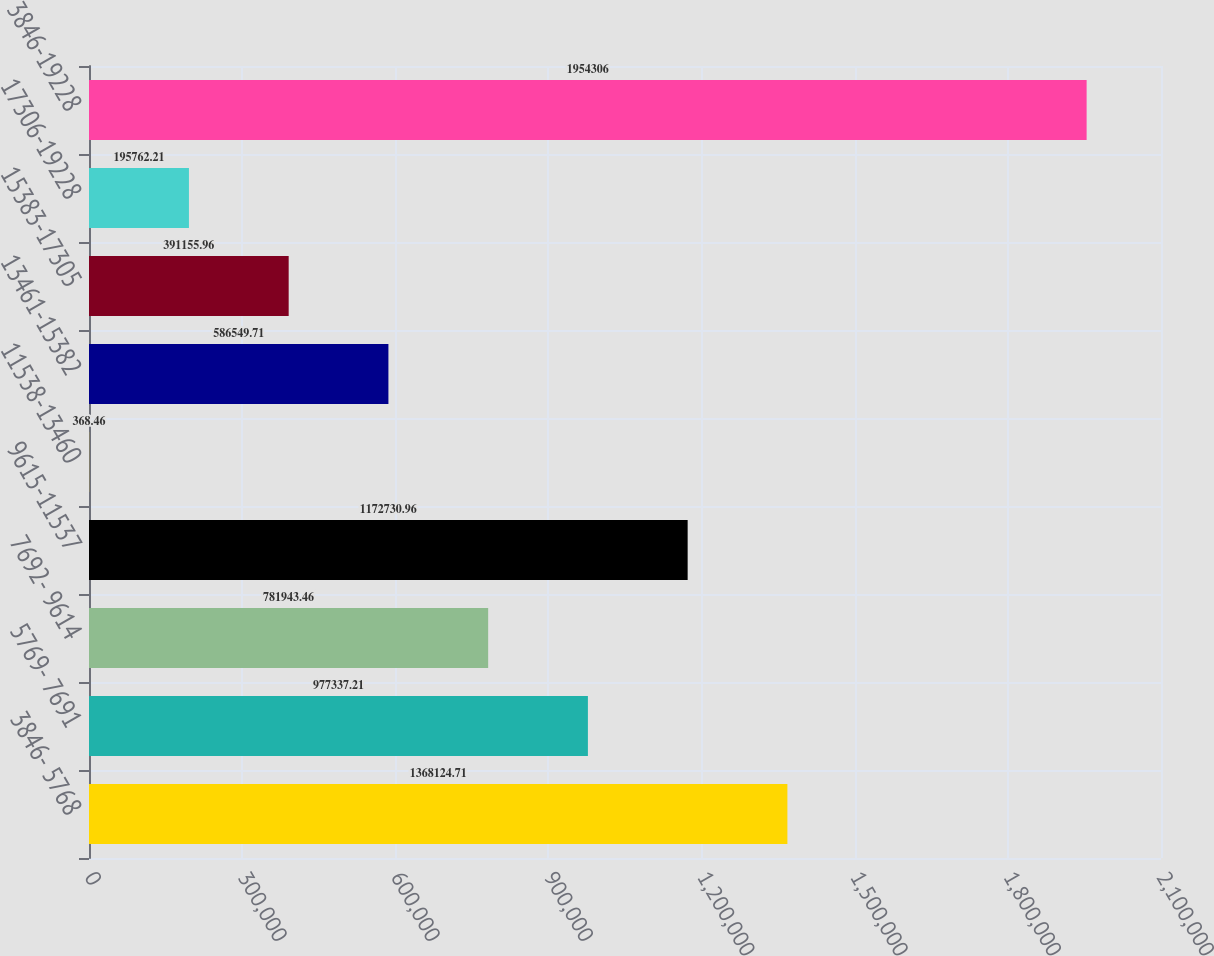<chart> <loc_0><loc_0><loc_500><loc_500><bar_chart><fcel>3846- 5768<fcel>5769- 7691<fcel>7692- 9614<fcel>9615-11537<fcel>11538-13460<fcel>13461-15382<fcel>15383-17305<fcel>17306-19228<fcel>3846-19228<nl><fcel>1.36812e+06<fcel>977337<fcel>781943<fcel>1.17273e+06<fcel>368.46<fcel>586550<fcel>391156<fcel>195762<fcel>1.95431e+06<nl></chart> 